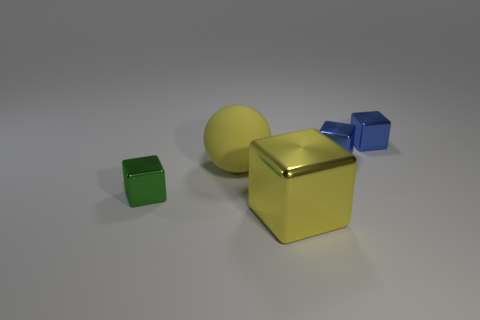Add 2 small cyan matte cubes. How many objects exist? 7 Subtract all blocks. How many objects are left? 1 Subtract 0 blue cylinders. How many objects are left? 5 Subtract all yellow rubber things. Subtract all red matte cylinders. How many objects are left? 4 Add 2 shiny cubes. How many shiny cubes are left? 6 Add 2 small blue metal things. How many small blue metal things exist? 4 